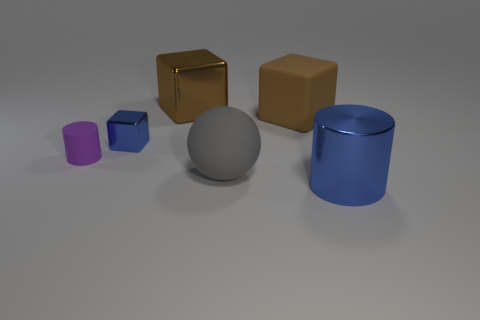How many objects are small objects to the left of the blue cube or cylinders behind the sphere?
Ensure brevity in your answer.  1. How many other objects are there of the same material as the purple thing?
Provide a succinct answer. 2. Does the small thing that is behind the small purple rubber cylinder have the same material as the big cylinder?
Provide a succinct answer. Yes. Are there more large things behind the blue block than large things in front of the small cylinder?
Give a very brief answer. No. How many objects are brown objects that are right of the big sphere or tiny purple matte cylinders?
Keep it short and to the point. 2. There is another tiny thing that is made of the same material as the gray object; what shape is it?
Provide a succinct answer. Cylinder. Are there any other things that are the same shape as the gray matte object?
Provide a succinct answer. No. What color is the cube that is both behind the tiny blue metallic thing and on the left side of the matte sphere?
Keep it short and to the point. Brown. What number of cubes are either brown shiny things or brown matte objects?
Your response must be concise. 2. How many other brown balls have the same size as the rubber sphere?
Offer a very short reply. 0. 